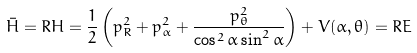<formula> <loc_0><loc_0><loc_500><loc_500>\bar { H } = R H = \frac { 1 } { 2 } \left ( p _ { R } ^ { 2 } + p _ { \alpha } ^ { 2 } + \frac { p _ { \theta } ^ { 2 } } { \cos ^ { 2 } \alpha \sin ^ { 2 } \alpha } \right ) + V ( \alpha , \theta ) = R E \,</formula> 